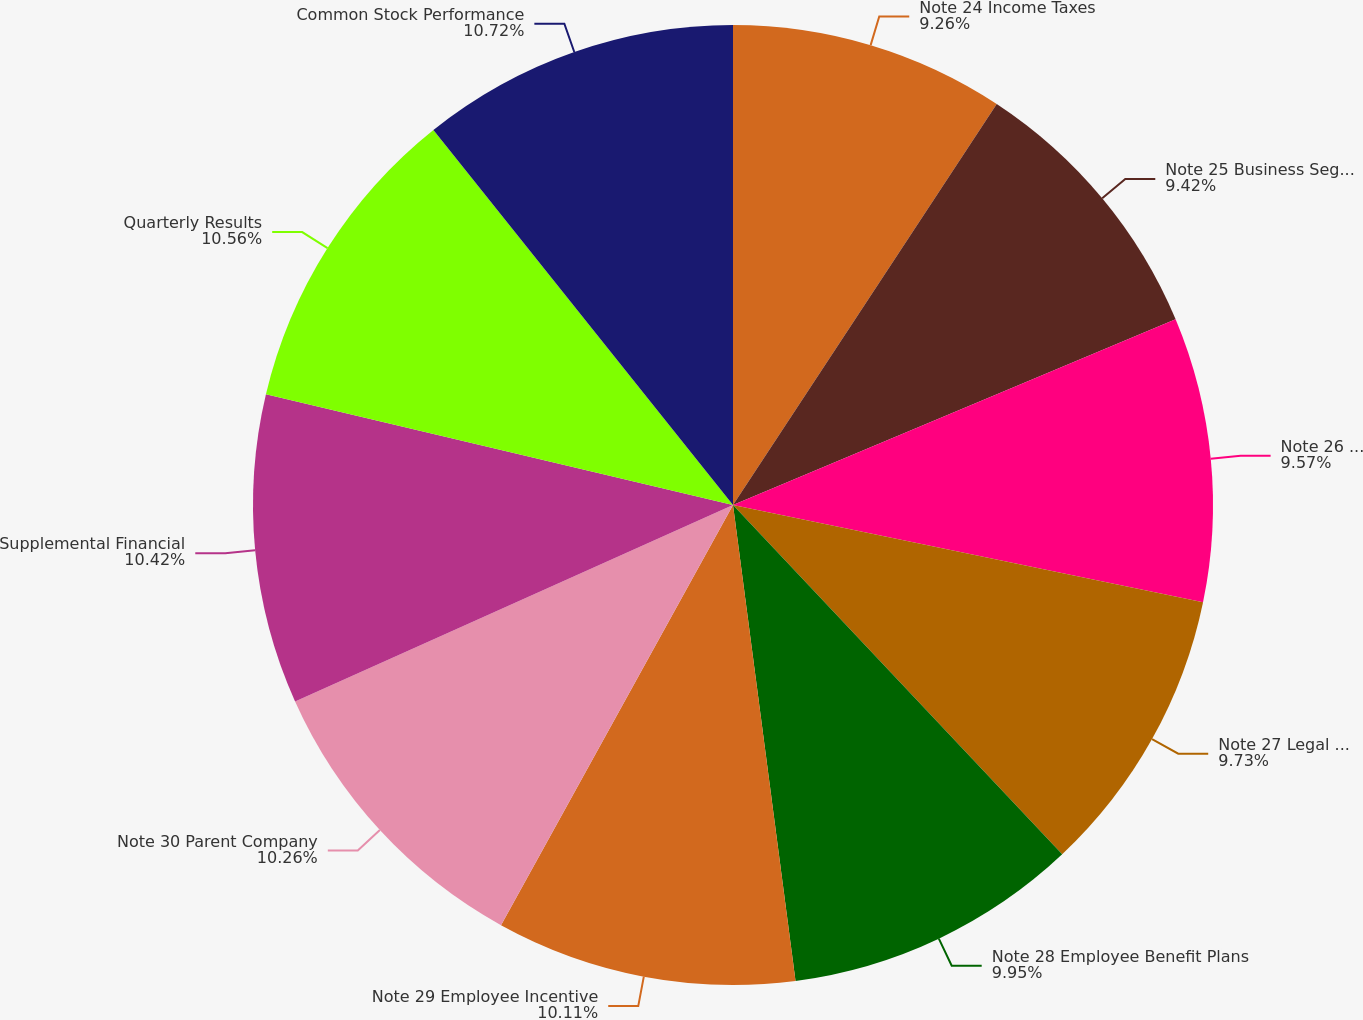<chart> <loc_0><loc_0><loc_500><loc_500><pie_chart><fcel>Note 24 Income Taxes<fcel>Note 25 Business Segments<fcel>Note 26 Credit Concentrations<fcel>Note 27 Legal Proceedings<fcel>Note 28 Employee Benefit Plans<fcel>Note 29 Employee Incentive<fcel>Note 30 Parent Company<fcel>Supplemental Financial<fcel>Quarterly Results<fcel>Common Stock Performance<nl><fcel>9.26%<fcel>9.42%<fcel>9.57%<fcel>9.73%<fcel>9.95%<fcel>10.11%<fcel>10.26%<fcel>10.42%<fcel>10.57%<fcel>10.73%<nl></chart> 